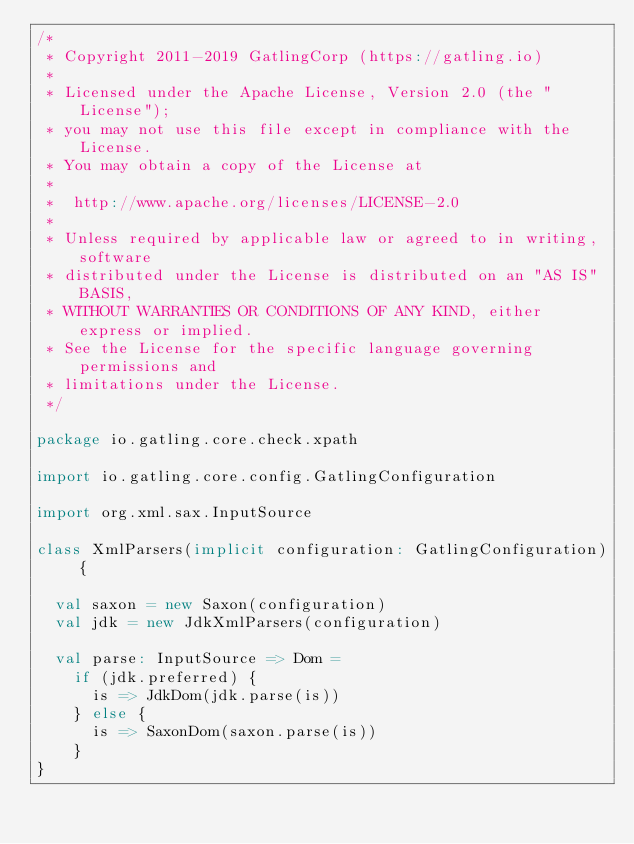Convert code to text. <code><loc_0><loc_0><loc_500><loc_500><_Scala_>/*
 * Copyright 2011-2019 GatlingCorp (https://gatling.io)
 *
 * Licensed under the Apache License, Version 2.0 (the "License");
 * you may not use this file except in compliance with the License.
 * You may obtain a copy of the License at
 *
 *  http://www.apache.org/licenses/LICENSE-2.0
 *
 * Unless required by applicable law or agreed to in writing, software
 * distributed under the License is distributed on an "AS IS" BASIS,
 * WITHOUT WARRANTIES OR CONDITIONS OF ANY KIND, either express or implied.
 * See the License for the specific language governing permissions and
 * limitations under the License.
 */

package io.gatling.core.check.xpath

import io.gatling.core.config.GatlingConfiguration

import org.xml.sax.InputSource

class XmlParsers(implicit configuration: GatlingConfiguration) {

  val saxon = new Saxon(configuration)
  val jdk = new JdkXmlParsers(configuration)

  val parse: InputSource => Dom =
    if (jdk.preferred) {
      is => JdkDom(jdk.parse(is))
    } else {
      is => SaxonDom(saxon.parse(is))
    }
}
</code> 